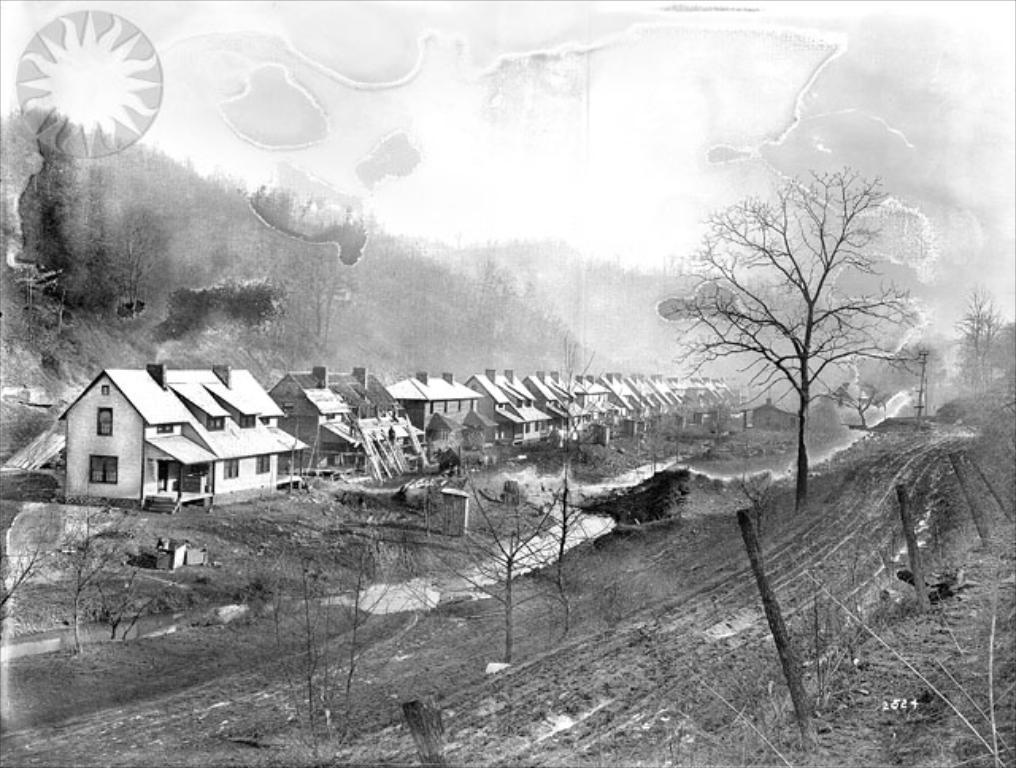What structures are located in the left corner of the image? There are buildings in the left corner of the image. What can be seen in the right corner of the image? There are dried trees and a fence in the right corner of the image. What type of vegetation is visible in the background of the image? There are trees in the background of the image. What event is being written about in the image? There is no writing or event depicted in the image. What is the image's reaction to the dried trees? The image does not have a reaction, as it is a static image. 